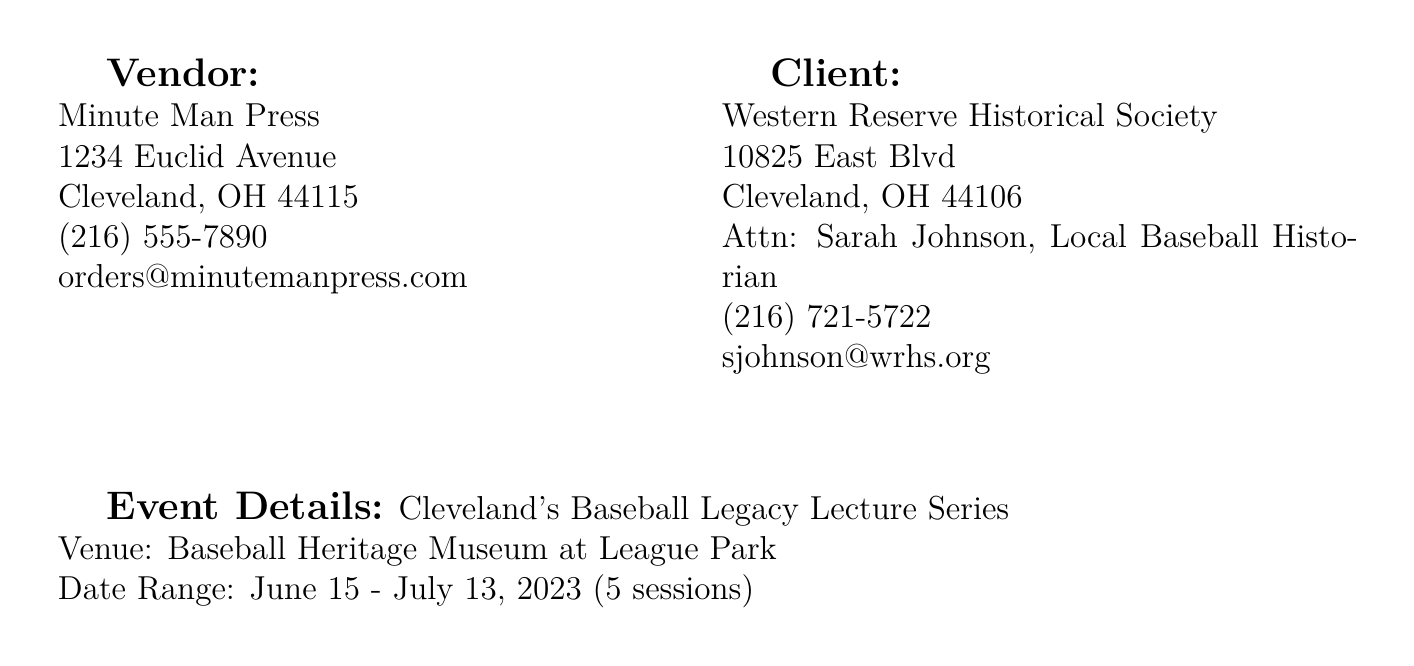What is the name of the vendor? The vendor's name, as listed in the document, is Minute Man Press.
Answer: Minute Man Press How many commemorative programs were printed? The document specifies that 500 commemorative programs were printed.
Answer: 500 What is the unit price for the printing of event tickets? According to the invoice, the unit price for printing of event tickets is $0.85.
Answer: $0.85 What is the total cost for design services for the commemorative program? The total cost is calculated by multiplying the quantity (1) by the unit price ($450.00), resulting in $450.00.
Answer: $450.00 What is the total amount due on the invoice? The total amount due is the sum of all items listed, which is $4,650.00.
Answer: $4,650.00 Who is the contact person for the client? The contact person for the client, as mentioned in the document, is Sarah Johnson.
Answer: Sarah Johnson What type of paper was used for the program covers? The document specifies that textured, heavyweight paper featuring vintage baseball leather texture was used for program covers.
Answer: Textured, heavyweight paper What is the date range for the lecture series? The document states that the date range for the lecture series is June 15 - July 13, 2023.
Answer: June 15 - July 13, 2023 How much is the rush printing fee? The document lists the rush printing fee as $175.00.
Answer: $175.00 